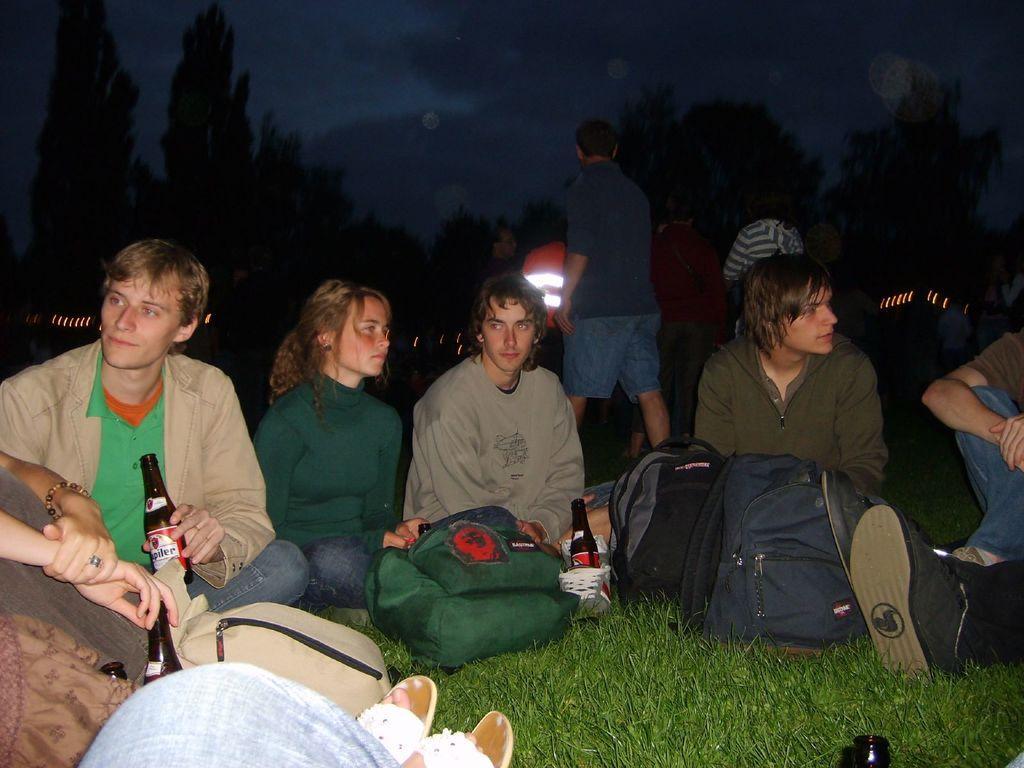Please provide a concise description of this image. This image consists of so many persons in the middle. There are bags in front of them. Some of them are holding bottles. There is sky at the top. There are trees at the top. 